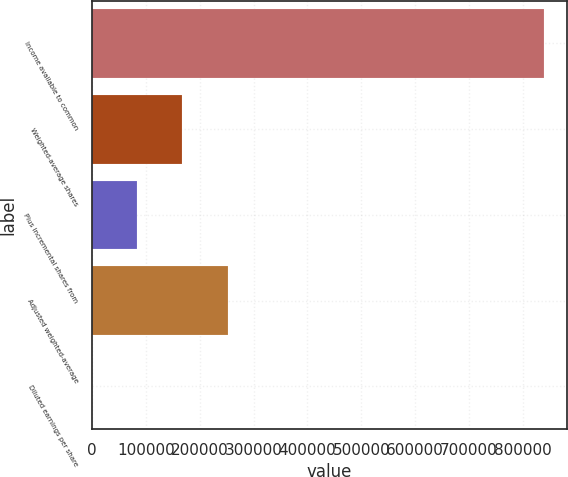Convert chart. <chart><loc_0><loc_0><loc_500><loc_500><bar_chart><fcel>Income available to common<fcel>Weighted-average shares<fcel>Plus incremental shares from<fcel>Adjusted weighted-average<fcel>Diluted earnings per share<nl><fcel>839189<fcel>167844<fcel>83925.5<fcel>251762<fcel>7.37<nl></chart> 